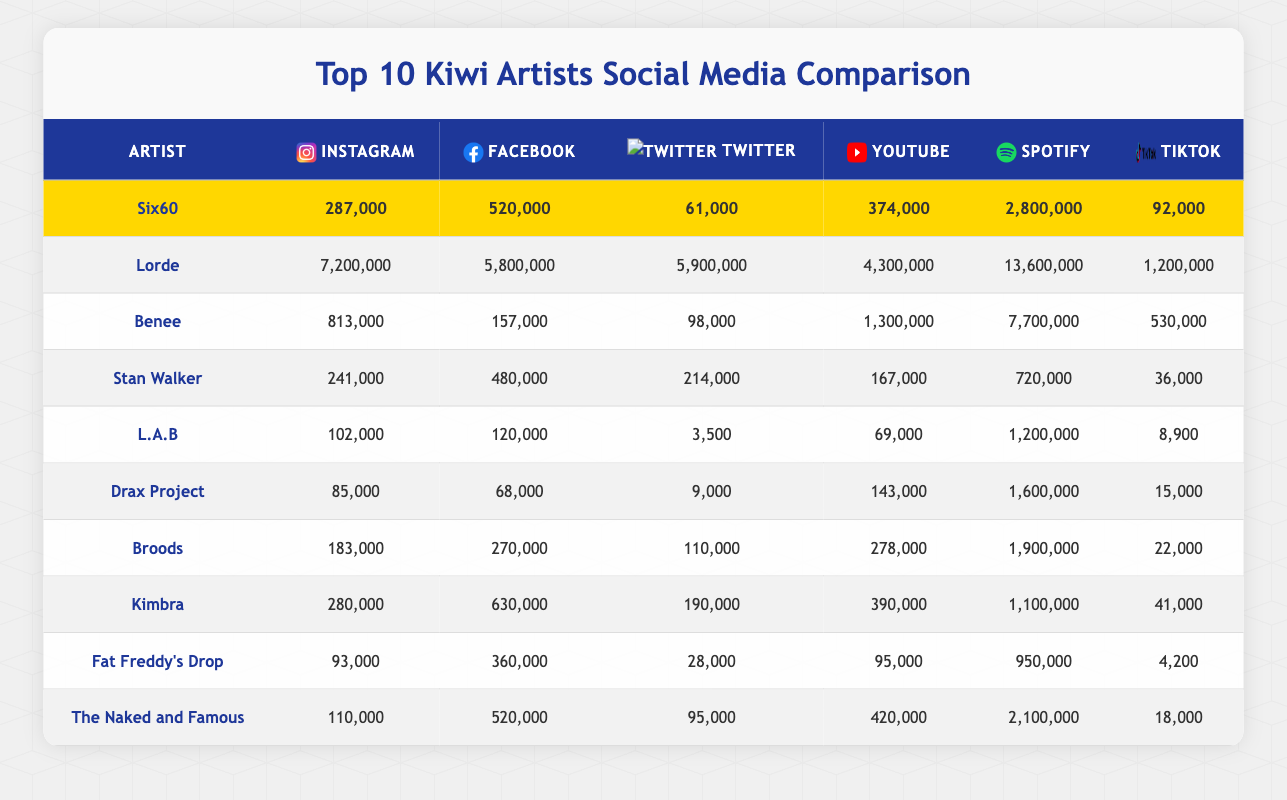What are the total Instagram followers for all artists combined? To find the total Instagram followers, sum the Instagram followers of all artists: 287,000 (Six60) + 7,200,000 (Lorde) + 813,000 (Benee) + 241,000 (Stan Walker) + 102,000 (L.A.B) + 85,000 (Drax Project) + 183,000 (Broods) + 280,000 (Kimbra) + 93,000 (Fat Freddy's Drop) + 110,000 (The Naked and Famous) = 8,226,000
Answer: 8,226,000 Which artist has the highest number of Spotify monthly listeners? By comparing the Spotify monthly listeners of all artists, it is clear that Lorde has the highest value at 13,600,000.
Answer: Lorde How many more Twitter followers does Benee have compared to Fat Freddy's Drop? To find the difference, subtract Fat Freddy's Drop's Twitter followers (28,000) from Benee's Twitter followers (98,000): 98,000 - 28,000 = 70,000.
Answer: 70,000 Is it true that Six60 has more Facebook likes than Kimbra? Comparing Facebook likes, Six60 has 520,000 while Kimbra has 630,000, thus the statement is false.
Answer: No What artist has the closest number of YouTube subscribers to Stan Walker? Looking at Stan Walker's YouTube subscribers (167,000), the closest is Drax Project with 143,000, which is a difference of 24,000 subscribers.
Answer: Drax Project 